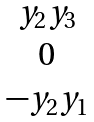Convert formula to latex. <formula><loc_0><loc_0><loc_500><loc_500>\begin{matrix} y _ { 2 } y _ { 3 } \\ 0 \\ - y _ { 2 } y _ { 1 } \end{matrix}</formula> 